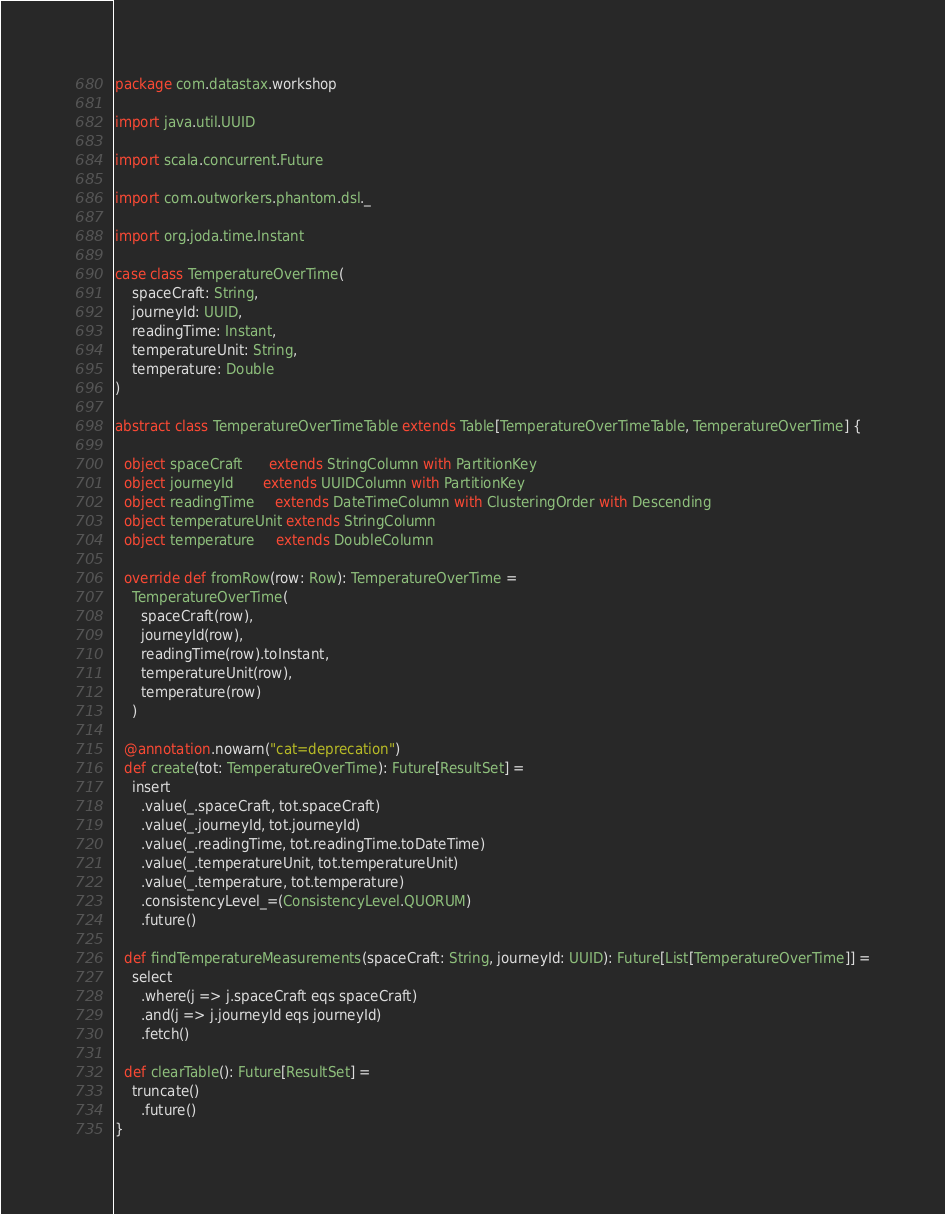<code> <loc_0><loc_0><loc_500><loc_500><_Scala_>package com.datastax.workshop

import java.util.UUID

import scala.concurrent.Future

import com.outworkers.phantom.dsl._

import org.joda.time.Instant

case class TemperatureOverTime(
    spaceCraft: String,
    journeyId: UUID,
    readingTime: Instant,
    temperatureUnit: String,
    temperature: Double
)

abstract class TemperatureOverTimeTable extends Table[TemperatureOverTimeTable, TemperatureOverTime] {

  object spaceCraft      extends StringColumn with PartitionKey
  object journeyId       extends UUIDColumn with PartitionKey
  object readingTime     extends DateTimeColumn with ClusteringOrder with Descending
  object temperatureUnit extends StringColumn
  object temperature     extends DoubleColumn

  override def fromRow(row: Row): TemperatureOverTime =
    TemperatureOverTime(
      spaceCraft(row),
      journeyId(row),
      readingTime(row).toInstant,
      temperatureUnit(row),
      temperature(row)
    )

  @annotation.nowarn("cat=deprecation")
  def create(tot: TemperatureOverTime): Future[ResultSet] =
    insert
      .value(_.spaceCraft, tot.spaceCraft)
      .value(_.journeyId, tot.journeyId)
      .value(_.readingTime, tot.readingTime.toDateTime)
      .value(_.temperatureUnit, tot.temperatureUnit)
      .value(_.temperature, tot.temperature)
      .consistencyLevel_=(ConsistencyLevel.QUORUM)
      .future()

  def findTemperatureMeasurements(spaceCraft: String, journeyId: UUID): Future[List[TemperatureOverTime]] =
    select
      .where(j => j.spaceCraft eqs spaceCraft)
      .and(j => j.journeyId eqs journeyId)
      .fetch()

  def clearTable(): Future[ResultSet] =
    truncate()
      .future()
}
</code> 